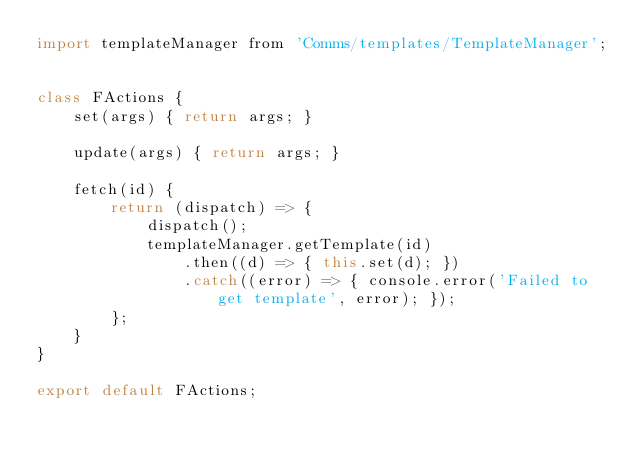Convert code to text. <code><loc_0><loc_0><loc_500><loc_500><_JavaScript_>import templateManager from 'Comms/templates/TemplateManager';


class FActions {
    set(args) { return args; }

    update(args) { return args; }

    fetch(id) {
        return (dispatch) => {
            dispatch();
            templateManager.getTemplate(id)
                .then((d) => { this.set(d); })
                .catch((error) => { console.error('Failed to get template', error); });
        };
    }
}

export default FActions;
</code> 